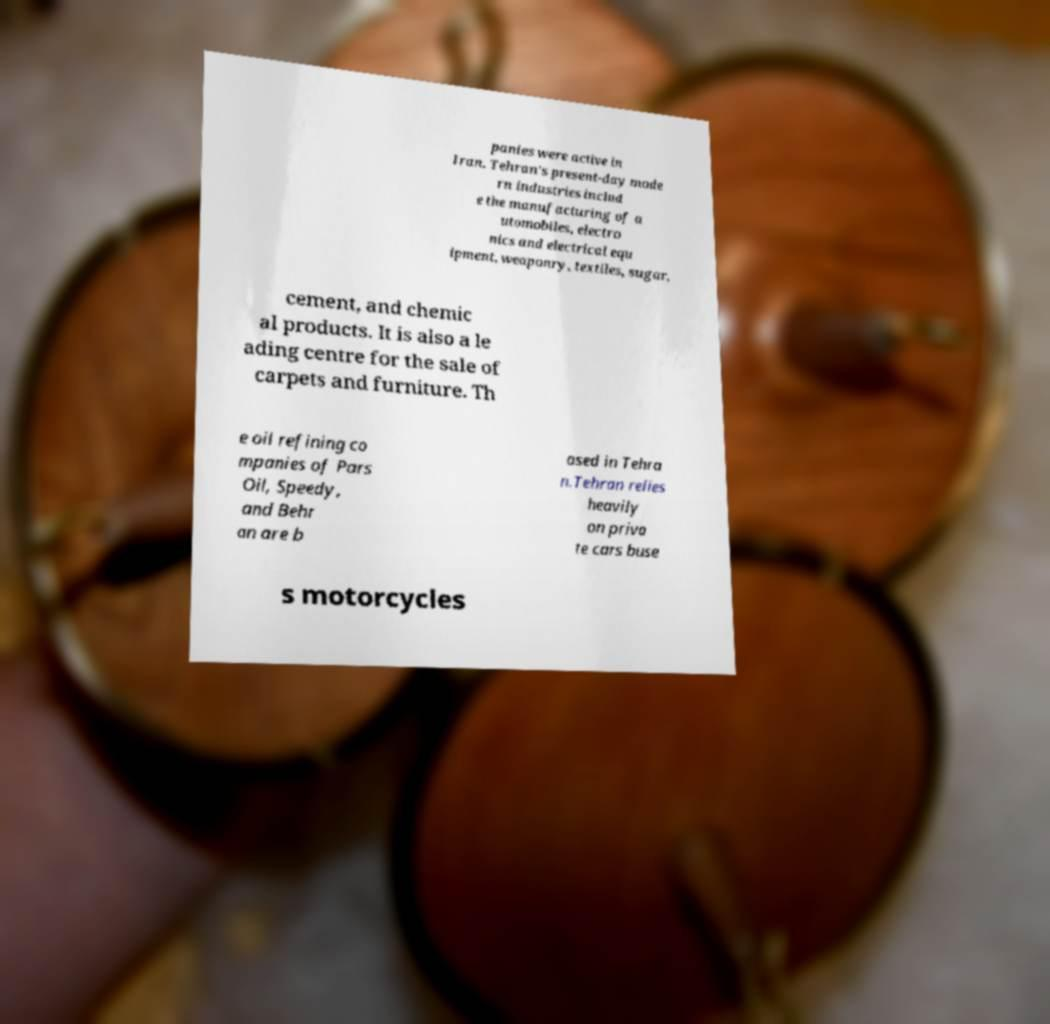Please read and relay the text visible in this image. What does it say? panies were active in Iran. Tehran's present-day mode rn industries includ e the manufacturing of a utomobiles, electro nics and electrical equ ipment, weaponry, textiles, sugar, cement, and chemic al products. It is also a le ading centre for the sale of carpets and furniture. Th e oil refining co mpanies of Pars Oil, Speedy, and Behr an are b ased in Tehra n.Tehran relies heavily on priva te cars buse s motorcycles 